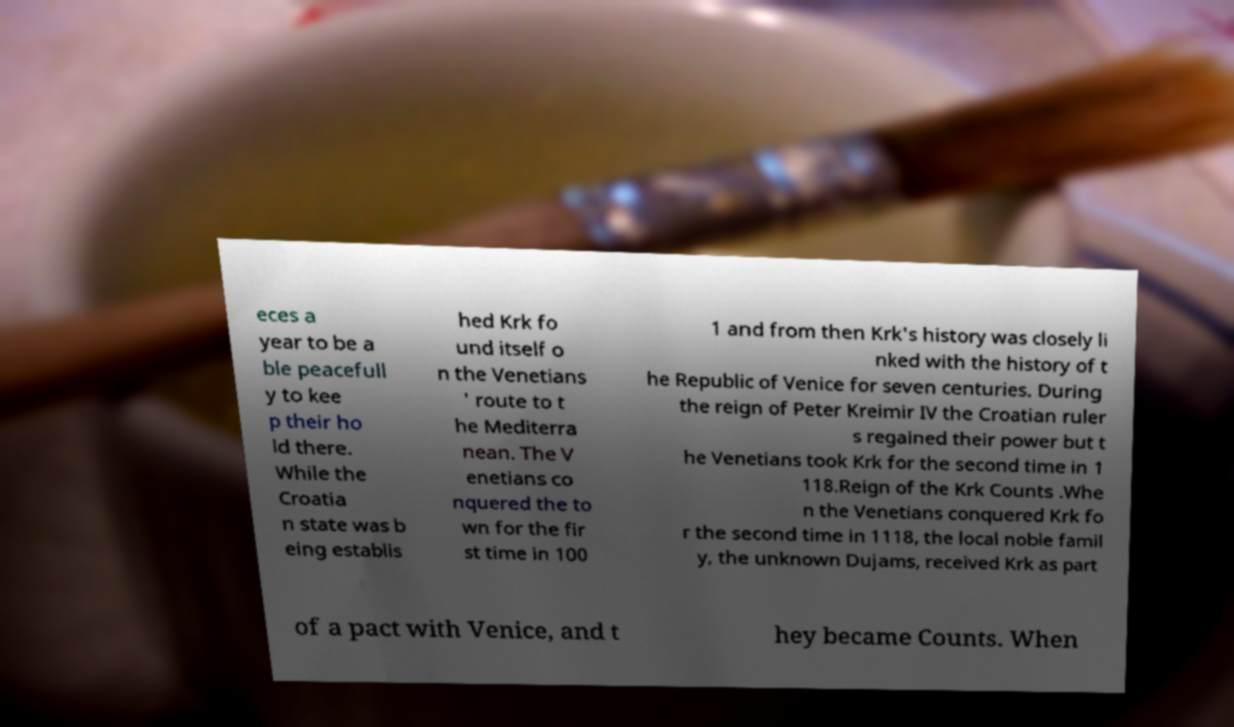For documentation purposes, I need the text within this image transcribed. Could you provide that? eces a year to be a ble peacefull y to kee p their ho ld there. While the Croatia n state was b eing establis hed Krk fo und itself o n the Venetians ' route to t he Mediterra nean. The V enetians co nquered the to wn for the fir st time in 100 1 and from then Krk's history was closely li nked with the history of t he Republic of Venice for seven centuries. During the reign of Peter Kreimir IV the Croatian ruler s regained their power but t he Venetians took Krk for the second time in 1 118.Reign of the Krk Counts .Whe n the Venetians conquered Krk fo r the second time in 1118, the local noble famil y, the unknown Dujams, received Krk as part of a pact with Venice, and t hey became Counts. When 